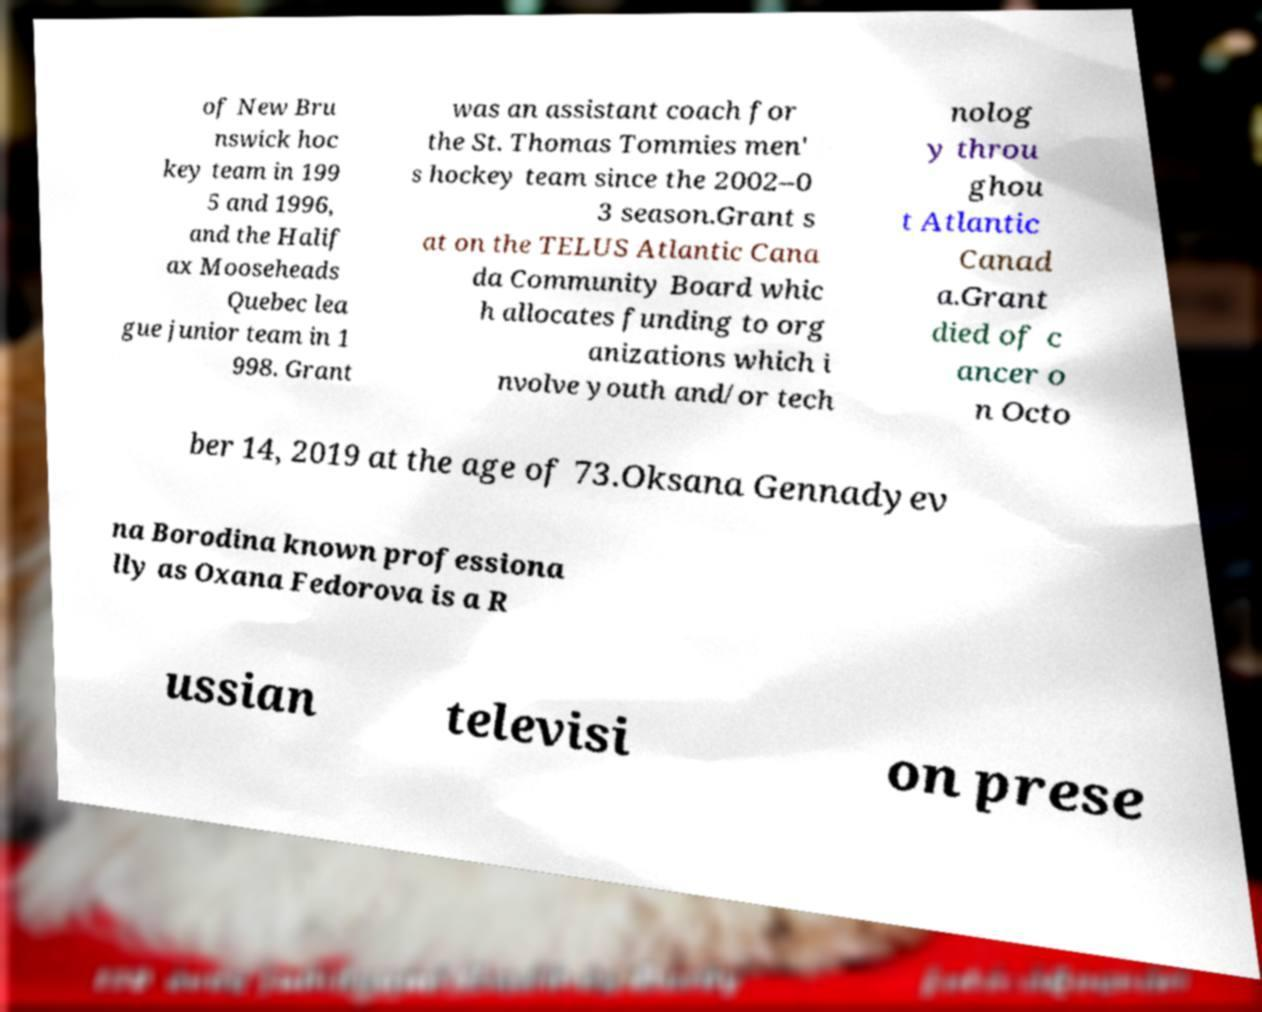Could you extract and type out the text from this image? of New Bru nswick hoc key team in 199 5 and 1996, and the Halif ax Mooseheads Quebec lea gue junior team in 1 998. Grant was an assistant coach for the St. Thomas Tommies men' s hockey team since the 2002–0 3 season.Grant s at on the TELUS Atlantic Cana da Community Board whic h allocates funding to org anizations which i nvolve youth and/or tech nolog y throu ghou t Atlantic Canad a.Grant died of c ancer o n Octo ber 14, 2019 at the age of 73.Oksana Gennadyev na Borodina known professiona lly as Oxana Fedorova is a R ussian televisi on prese 